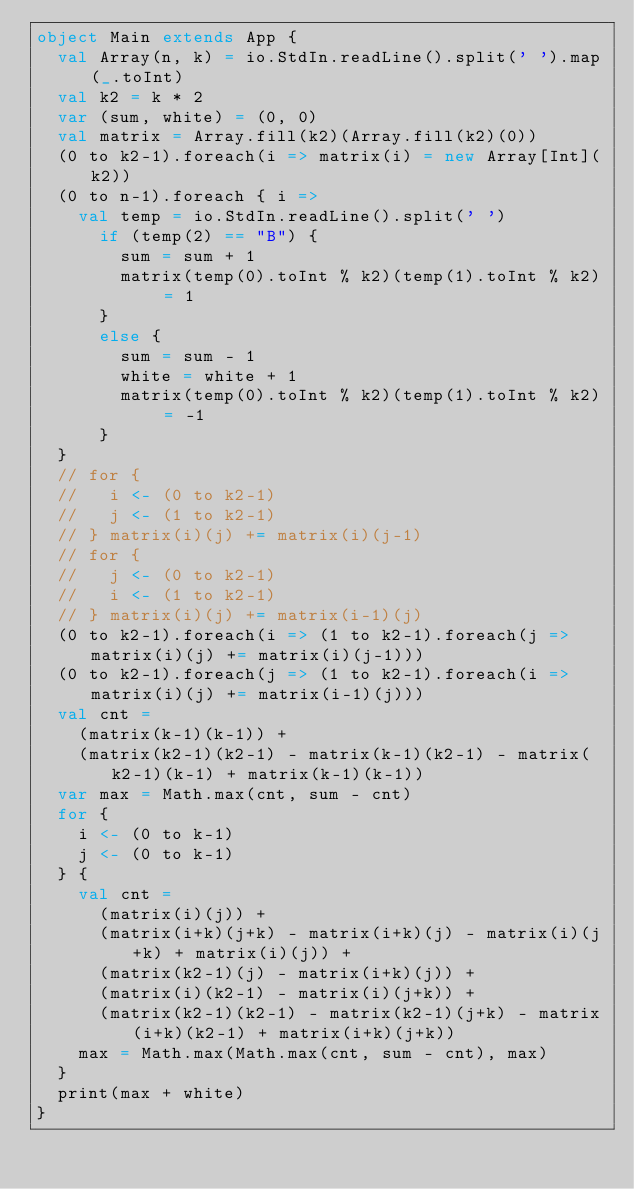Convert code to text. <code><loc_0><loc_0><loc_500><loc_500><_Scala_>object Main extends App {
  val Array(n, k) = io.StdIn.readLine().split(' ').map(_.toInt)
  val k2 = k * 2
  var (sum, white) = (0, 0)
  val matrix = Array.fill(k2)(Array.fill(k2)(0))
  (0 to k2-1).foreach(i => matrix(i) = new Array[Int](k2))
  (0 to n-1).foreach { i =>
    val temp = io.StdIn.readLine().split(' ')
      if (temp(2) == "B") {
        sum = sum + 1
        matrix(temp(0).toInt % k2)(temp(1).toInt % k2) = 1
      }
      else {
        sum = sum - 1
        white = white + 1
        matrix(temp(0).toInt % k2)(temp(1).toInt % k2) = -1
      }
  }
  // for {
  //   i <- (0 to k2-1)
  //   j <- (1 to k2-1)
  // } matrix(i)(j) += matrix(i)(j-1)
  // for {
  //   j <- (0 to k2-1)
  //   i <- (1 to k2-1)
  // } matrix(i)(j) += matrix(i-1)(j)
  (0 to k2-1).foreach(i => (1 to k2-1).foreach(j => matrix(i)(j) += matrix(i)(j-1)))
  (0 to k2-1).foreach(j => (1 to k2-1).foreach(i => matrix(i)(j) += matrix(i-1)(j)))
  val cnt =
    (matrix(k-1)(k-1)) +
    (matrix(k2-1)(k2-1) - matrix(k-1)(k2-1) - matrix(k2-1)(k-1) + matrix(k-1)(k-1))
  var max = Math.max(cnt, sum - cnt)
  for { 
    i <- (0 to k-1)
    j <- (0 to k-1)
  } {
    val cnt = 
      (matrix(i)(j)) +
      (matrix(i+k)(j+k) - matrix(i+k)(j) - matrix(i)(j+k) + matrix(i)(j)) +
      (matrix(k2-1)(j) - matrix(i+k)(j)) +
      (matrix(i)(k2-1) - matrix(i)(j+k)) +
      (matrix(k2-1)(k2-1) - matrix(k2-1)(j+k) - matrix(i+k)(k2-1) + matrix(i+k)(j+k))
    max = Math.max(Math.max(cnt, sum - cnt), max)
  }
  print(max + white)
}
</code> 